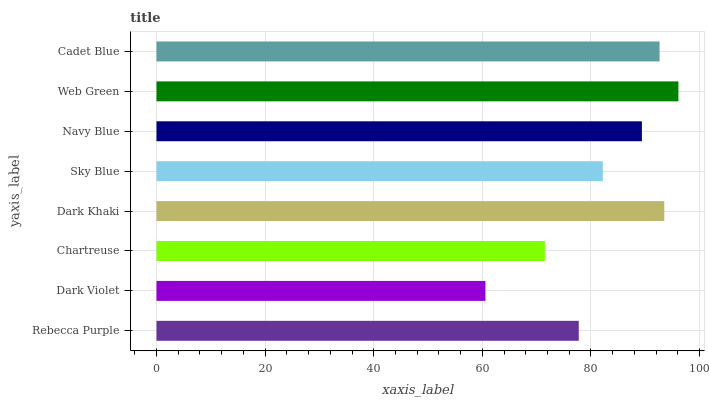Is Dark Violet the minimum?
Answer yes or no. Yes. Is Web Green the maximum?
Answer yes or no. Yes. Is Chartreuse the minimum?
Answer yes or no. No. Is Chartreuse the maximum?
Answer yes or no. No. Is Chartreuse greater than Dark Violet?
Answer yes or no. Yes. Is Dark Violet less than Chartreuse?
Answer yes or no. Yes. Is Dark Violet greater than Chartreuse?
Answer yes or no. No. Is Chartreuse less than Dark Violet?
Answer yes or no. No. Is Navy Blue the high median?
Answer yes or no. Yes. Is Sky Blue the low median?
Answer yes or no. Yes. Is Dark Violet the high median?
Answer yes or no. No. Is Chartreuse the low median?
Answer yes or no. No. 